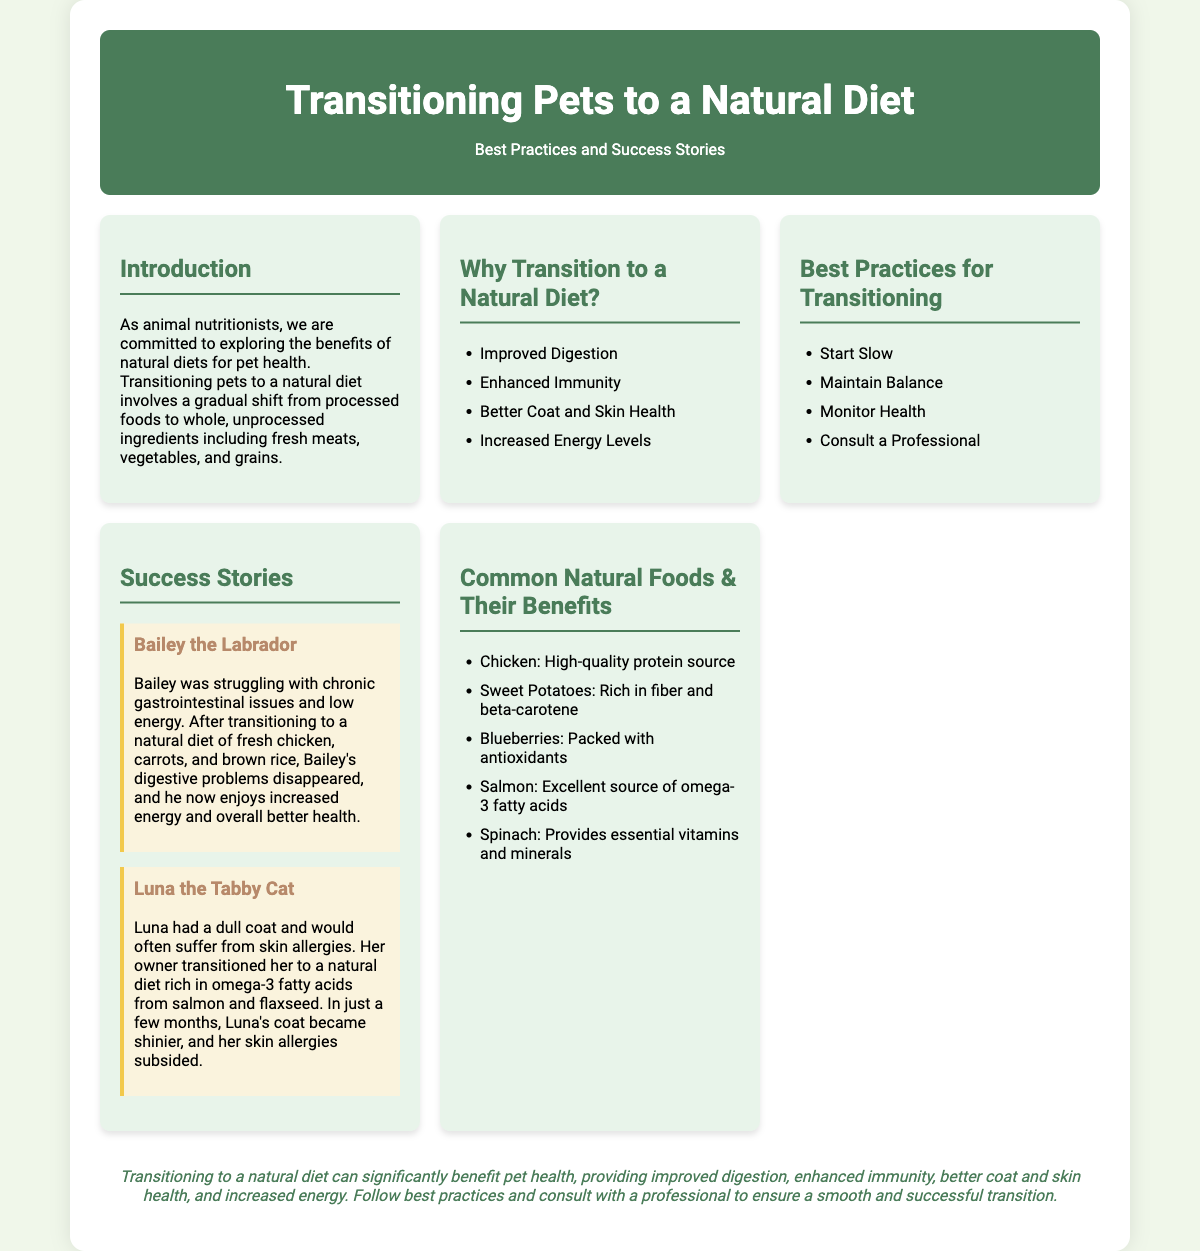What is the title of the poster? The title of the poster is prominently displayed at the top, presenting the main topic of the document.
Answer: Transitioning Pets to a Natural Diet What are two benefits of a natural diet mentioned? The poster lists several benefits under the "Why Transition to a Natural Diet?" section, highlighting key advantages of such diets.
Answer: Improved Digestion, Enhanced Immunity Who is Bailey? Bailey is introduced as a case study in the "Success Stories" section of the poster, detailing individual experiences with natural diets.
Answer: A Labrador What food was Luna's diet enriched with? The specific food sources that improved Luna's health are detailed in the success story related to her.
Answer: Salmon How many best practices for transitioning are listed? The poster specifies a set of best practices under the corresponding section, clearly enumerating them.
Answer: Four What is a common natural food listed as beneficial? The "Common Natural Foods & Their Benefits" section includes various foods, highlighting their health benefits.
Answer: Chicken Which section discusses success stories? The content of the poster is organized into specific sections, addressing various topics including individual success stories related to natural diets.
Answer: Success Stories What is the concluding message about natural diets? The poster summarizes the overall benefits of transitioning to a natural diet in the conclusion, reinforcing key points.
Answer: Improved digestion, enhanced immunity, better coat and skin health, and increased energy What should you do before transitioning a pet to a natural diet? The best practices section includes a recommendation for consulting a professional, emphasizing careful planning.
Answer: Consult a Professional What color scheme is used for the header? The header's color scheme is specifically designed to stand out, enhancing the visual appeal and organization of the poster content.
Answer: Green and white 